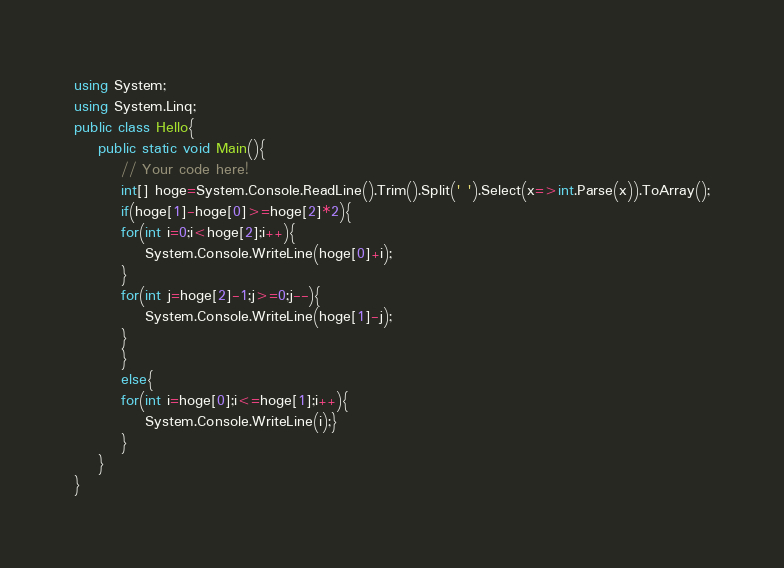Convert code to text. <code><loc_0><loc_0><loc_500><loc_500><_C#_>using System;
using System.Linq;
public class Hello{
    public static void Main(){
        // Your code here!
        int[] hoge=System.Console.ReadLine().Trim().Split(' ').Select(x=>int.Parse(x)).ToArray();
        if(hoge[1]-hoge[0]>=hoge[2]*2){
        for(int i=0;i<hoge[2];i++){
            System.Console.WriteLine(hoge[0]+i);
        }
        for(int j=hoge[2]-1;j>=0;j--){
            System.Console.WriteLine(hoge[1]-j);
        }
        }
        else{
        for(int i=hoge[0];i<=hoge[1];i++){
            System.Console.WriteLine(i);}
        }
    }
}
</code> 